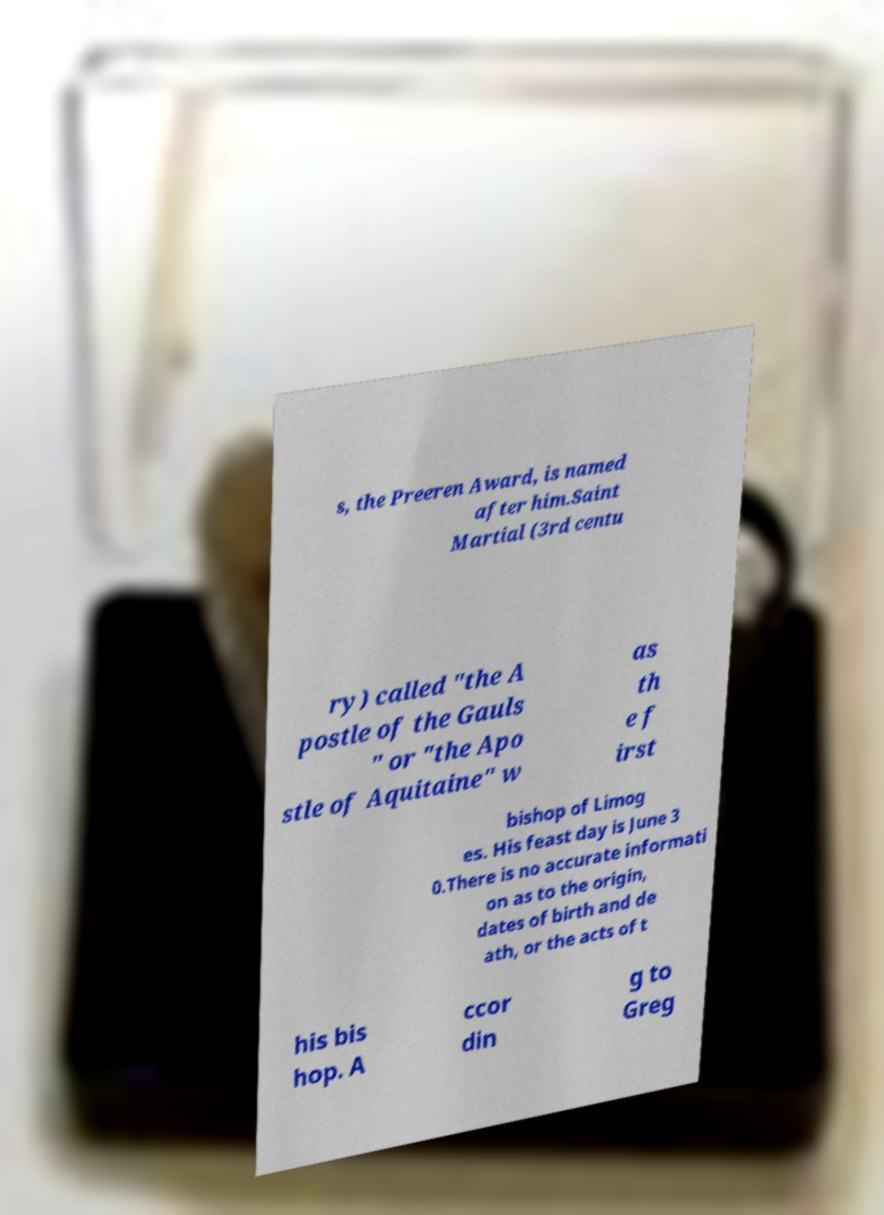Please read and relay the text visible in this image. What does it say? s, the Preeren Award, is named after him.Saint Martial (3rd centu ry) called "the A postle of the Gauls " or "the Apo stle of Aquitaine" w as th e f irst bishop of Limog es. His feast day is June 3 0.There is no accurate informati on as to the origin, dates of birth and de ath, or the acts of t his bis hop. A ccor din g to Greg 